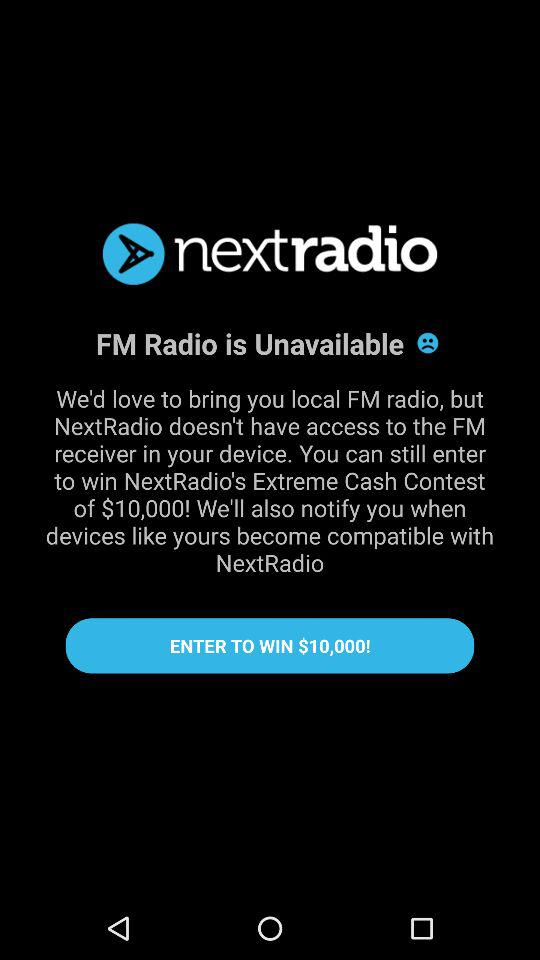What is the cash prize for Nextradio's extreme cash contest? The cash prize is $10,000. 